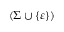<formula> <loc_0><loc_0><loc_500><loc_500>( \Sigma \cup \{ \varepsilon \} )</formula> 